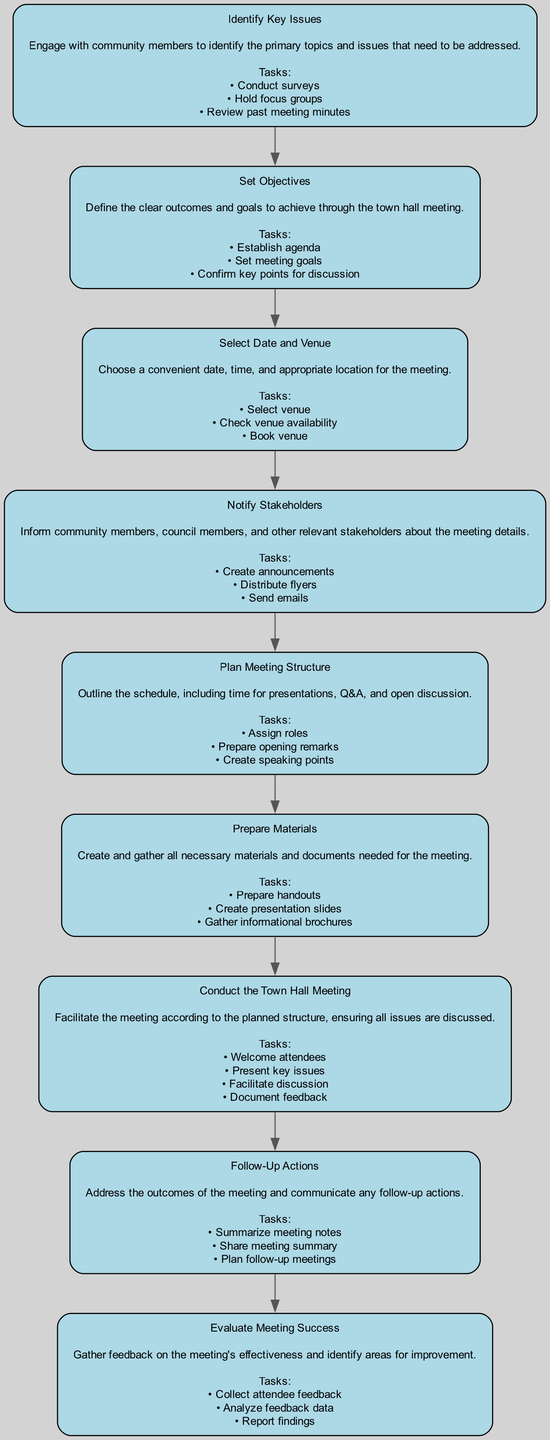What is the total number of steps in the flow chart? The diagram contains 9 steps representing different stages in organizing a town hall meeting. Each step is clearly labeled and numbered from 1 to 9.
Answer: 9 What step follows "Select Date and Venue"? "Notify Stakeholders" is the step that directly follows "Select Date and Venue" in the flow of organizing the town hall meeting, as indicated by the connection between the respective nodes.
Answer: Notify Stakeholders What are the primary tasks in the "Prepare Materials" step? The "Prepare Materials" step includes three primary tasks: prepare handouts, create presentation slides, and gather informational brochures, which are listed in the node description for that step.
Answer: Prepare handouts, create presentation slides, gather informational brochures Which step includes documenting feedback? "Conduct the Town Hall Meeting" includes the specific task of documenting feedback during the meeting, as stated in the tasks listed under that step's description.
Answer: Conduct the Town Hall Meeting What is the focus of the "Evaluate Meeting Success" step? The focus of this step is to gather feedback on the effectiveness of the meeting and identify areas for improvement. This reflects the purpose of evaluating the meeting's overall success.
Answer: Gather feedback on the meeting's effectiveness How many tasks are listed under the "Set Objectives" step? There are three tasks listed under "Set Objectives": establishing the agenda, setting meeting goals, and confirming key points for discussion, which corresponds to the information provided in that node.
Answer: 3 What does the "Identify Key Issues" step involve? The "Identify Key Issues" step involves engaging with community members to identify primary topics needing to be addressed, including conducting surveys, holding focus groups, and reviewing past meeting minutes.
Answer: Engaging with community members What is the relationship between "Notify Stakeholders" and "Conduct the Town Hall Meeting"? "Notify Stakeholders" precedes "Conduct the Town Hall Meeting" in the flow chart, indicating that informing stakeholders is necessary before facilitating the actual meeting.
Answer: Notify Stakeholders precedes Conduct the Town Hall Meeting What is the last step in the process outlined in the diagram? The last step in the flow chart for organizing a town hall meeting is "Evaluate Meeting Success," which concludes the outlined process.
Answer: Evaluate Meeting Success 